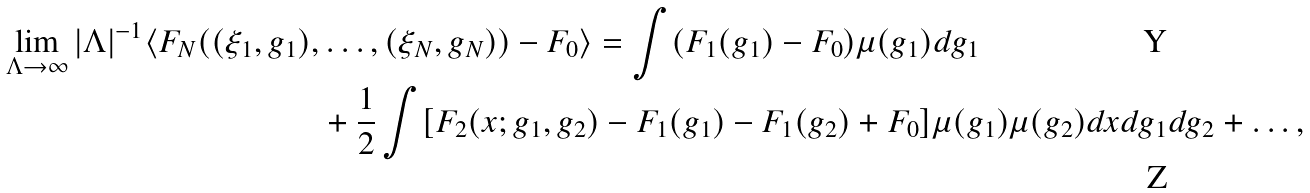Convert formula to latex. <formula><loc_0><loc_0><loc_500><loc_500>\lim _ { \Lambda \rightarrow \infty } | \Lambda | ^ { - 1 } \langle F _ { N } ( ( \xi _ { 1 } , g _ { 1 } ) , & \dots , ( \xi _ { N } , g _ { N } ) ) - F _ { 0 } \rangle = \int ( F _ { 1 } ( g _ { 1 } ) - F _ { 0 } ) \mu ( g _ { 1 } ) d g _ { 1 } \\ & + \frac { 1 } { 2 } \int [ F _ { 2 } ( x ; g _ { 1 } , g _ { 2 } ) - F _ { 1 } ( g _ { 1 } ) - F _ { 1 } ( g _ { 2 } ) + F _ { 0 } ] \mu ( g _ { 1 } ) \mu ( g _ { 2 } ) d x d g _ { 1 } d g _ { 2 } + \dots ,</formula> 